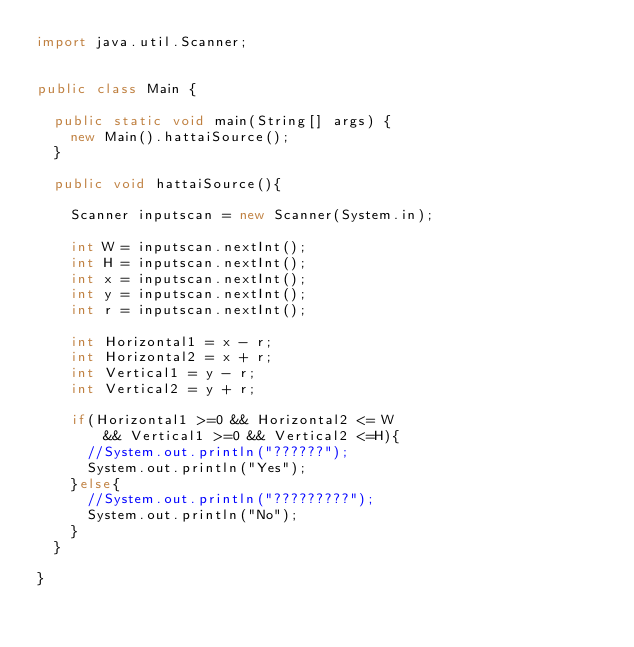Convert code to text. <code><loc_0><loc_0><loc_500><loc_500><_Java_>import java.util.Scanner;


public class Main {

	public static void main(String[] args) {
		new Main().hattaiSource();
	}

	public void hattaiSource(){

		Scanner inputscan = new Scanner(System.in);

		int W = inputscan.nextInt();
		int H = inputscan.nextInt();
		int x = inputscan.nextInt();
		int y = inputscan.nextInt();
		int r = inputscan.nextInt();

		int Horizontal1 = x - r;
		int Horizontal2 = x + r;
		int Vertical1 = y - r;
		int Vertical2 = y + r;

		if(Horizontal1 >=0 && Horizontal2 <= W
				&& Vertical1 >=0 && Vertical2 <=H){
			//System.out.println("??????");
			System.out.println("Yes");
		}else{
			//System.out.println("?????????");
			System.out.println("No");
		}
	}

}</code> 